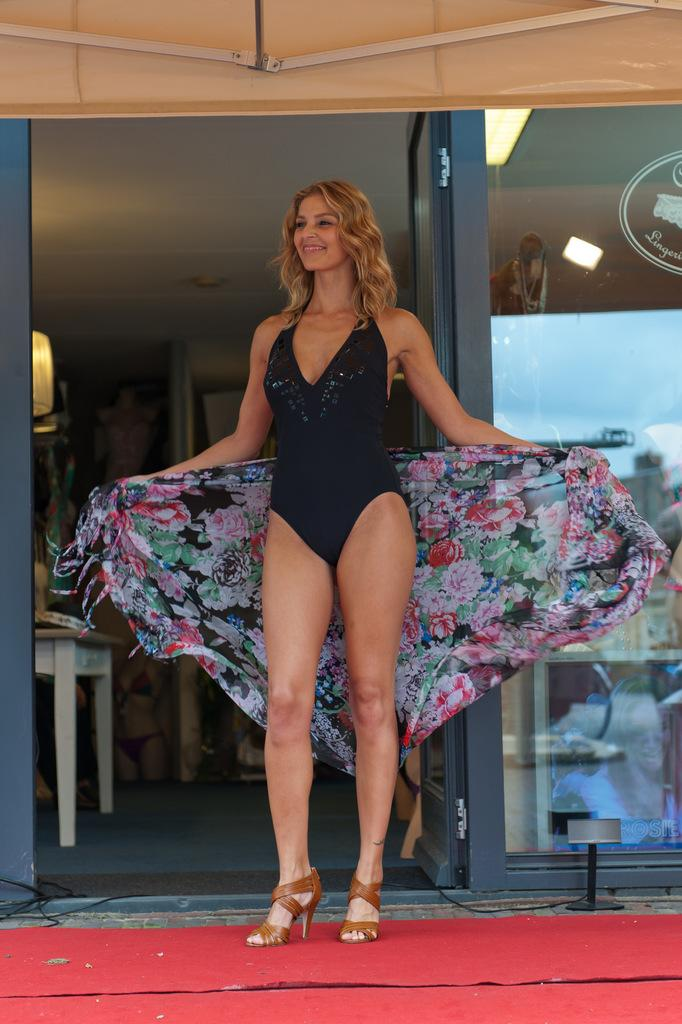Who is present in the image? There is a lady in the image. What is the lady holding in the image? The lady is holding a cloth. What is the lady's facial expression in the image? The lady is smiling. What is the lady standing on in the image? The lady is standing on a red carpet. What can be seen in the background of the image? There is a table, a door, and a glass wall in the background of the image. How many sheep are visible in the image? There are no sheep present in the image. What type of work is the lady performing in the image? The image does not provide any information about the lady's work, as it only shows her holding a cloth and standing on a red carpet. 